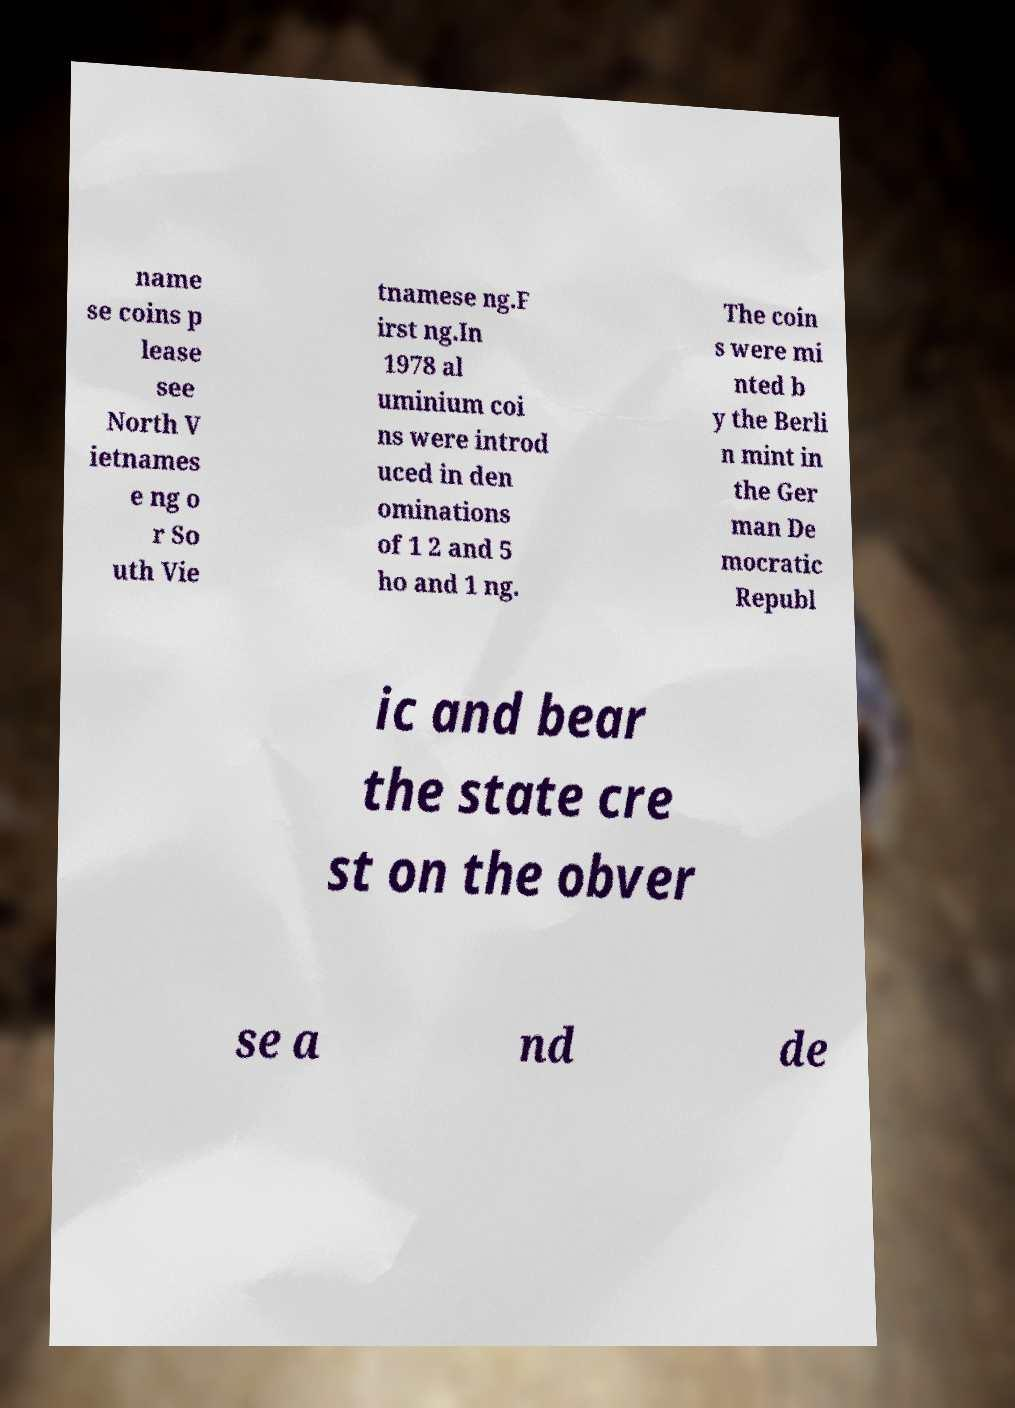For documentation purposes, I need the text within this image transcribed. Could you provide that? name se coins p lease see North V ietnames e ng o r So uth Vie tnamese ng.F irst ng.In 1978 al uminium coi ns were introd uced in den ominations of 1 2 and 5 ho and 1 ng. The coin s were mi nted b y the Berli n mint in the Ger man De mocratic Republ ic and bear the state cre st on the obver se a nd de 